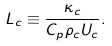<formula> <loc_0><loc_0><loc_500><loc_500>L _ { c } \equiv \frac { \kappa _ { c } } { C _ { p } \rho _ { c } U _ { c } } .</formula> 